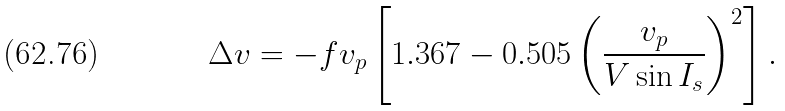Convert formula to latex. <formula><loc_0><loc_0><loc_500><loc_500>\Delta v = - f v _ { p } \left [ 1 . 3 6 7 - 0 . 5 0 5 \left ( \frac { v _ { p } } { V \sin I _ { s } } \right ) ^ { 2 } \right ] .</formula> 